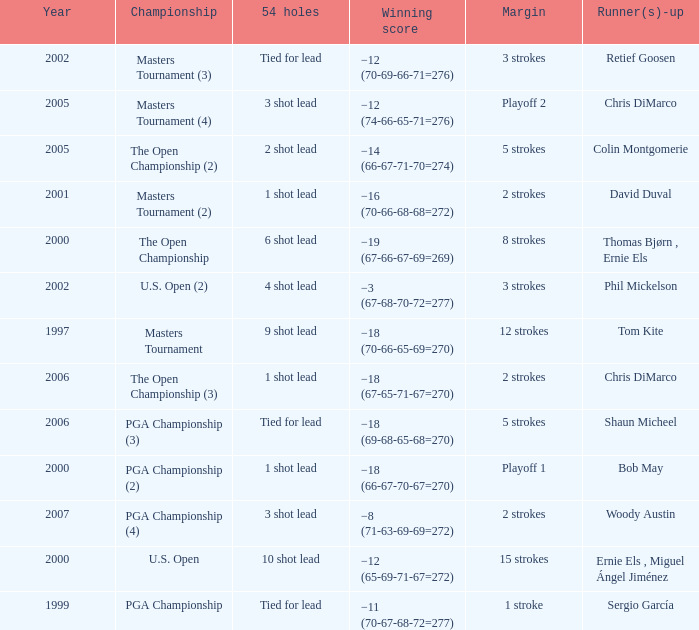 who is the runner(s)-up where 54 holes is tied for lead and margin is 5 strokes Shaun Micheel. 